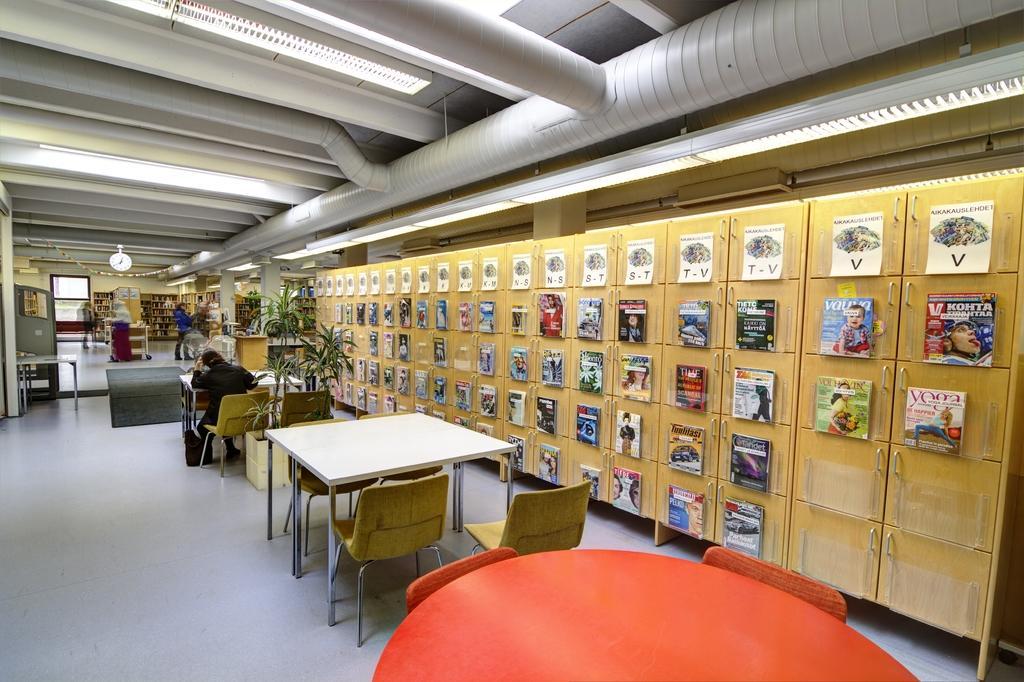Can you describe this image briefly? In this picture we can see a person sitting on the chair. These are the tables and these are the chairs. This is the floor. And even we can see a person standing here. This is the roof and these are the lights. Here we can see a cupboard. 